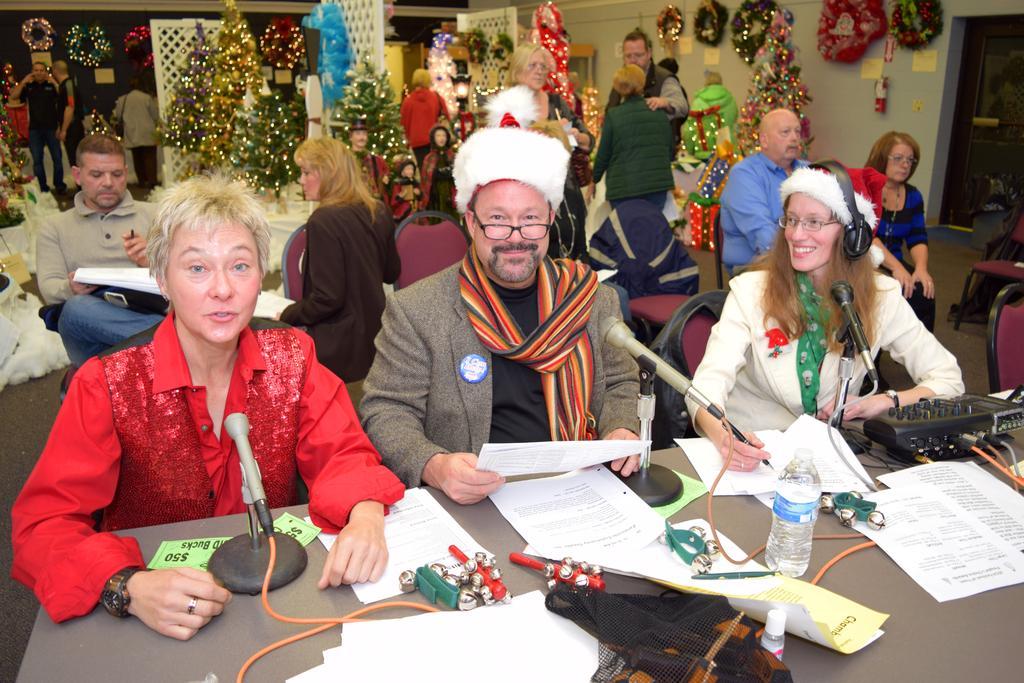Describe this image in one or two sentences. In this image we can see people sitting. There is a table and we can see chairs. We can see mics, bottle, papers and some objects placed on the table. In the background there are decors placed on the walls and we can see lights. There are xmas trees. On the right we can see a door. 